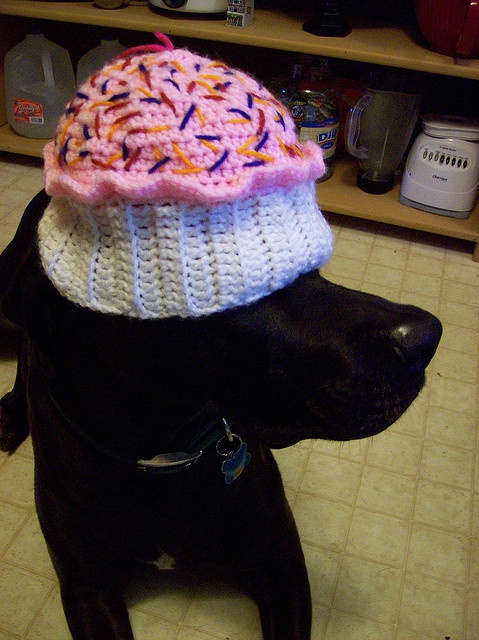Describe the objects in this image and their specific colors. I can see a dog in maroon, black, tan, pink, and darkgray tones in this image. 